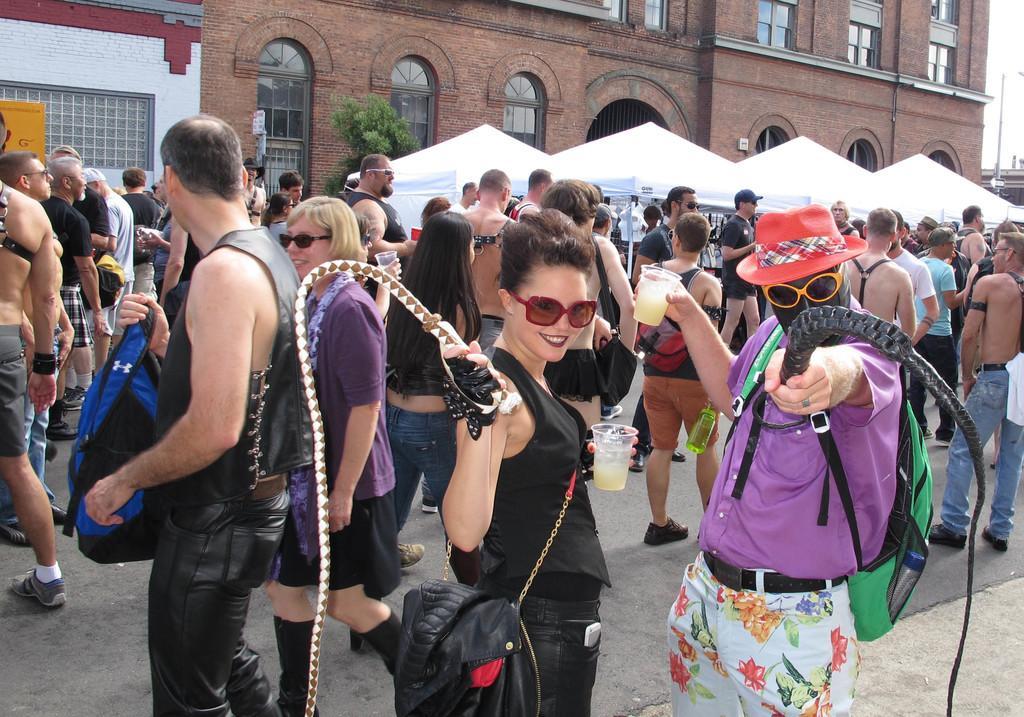Describe this image in one or two sentences. This image is taken outdoors. At the bottom of the image there is a road. In the background there is a building with walls, windows and doors. There are four tents. There is a tree and there is a pole with the street light. In the middle of the image many people are standing on the road and a few are walking on the road. A man and a woman are standing on the road and they are holding whips in their hands and they are holding glasses. 